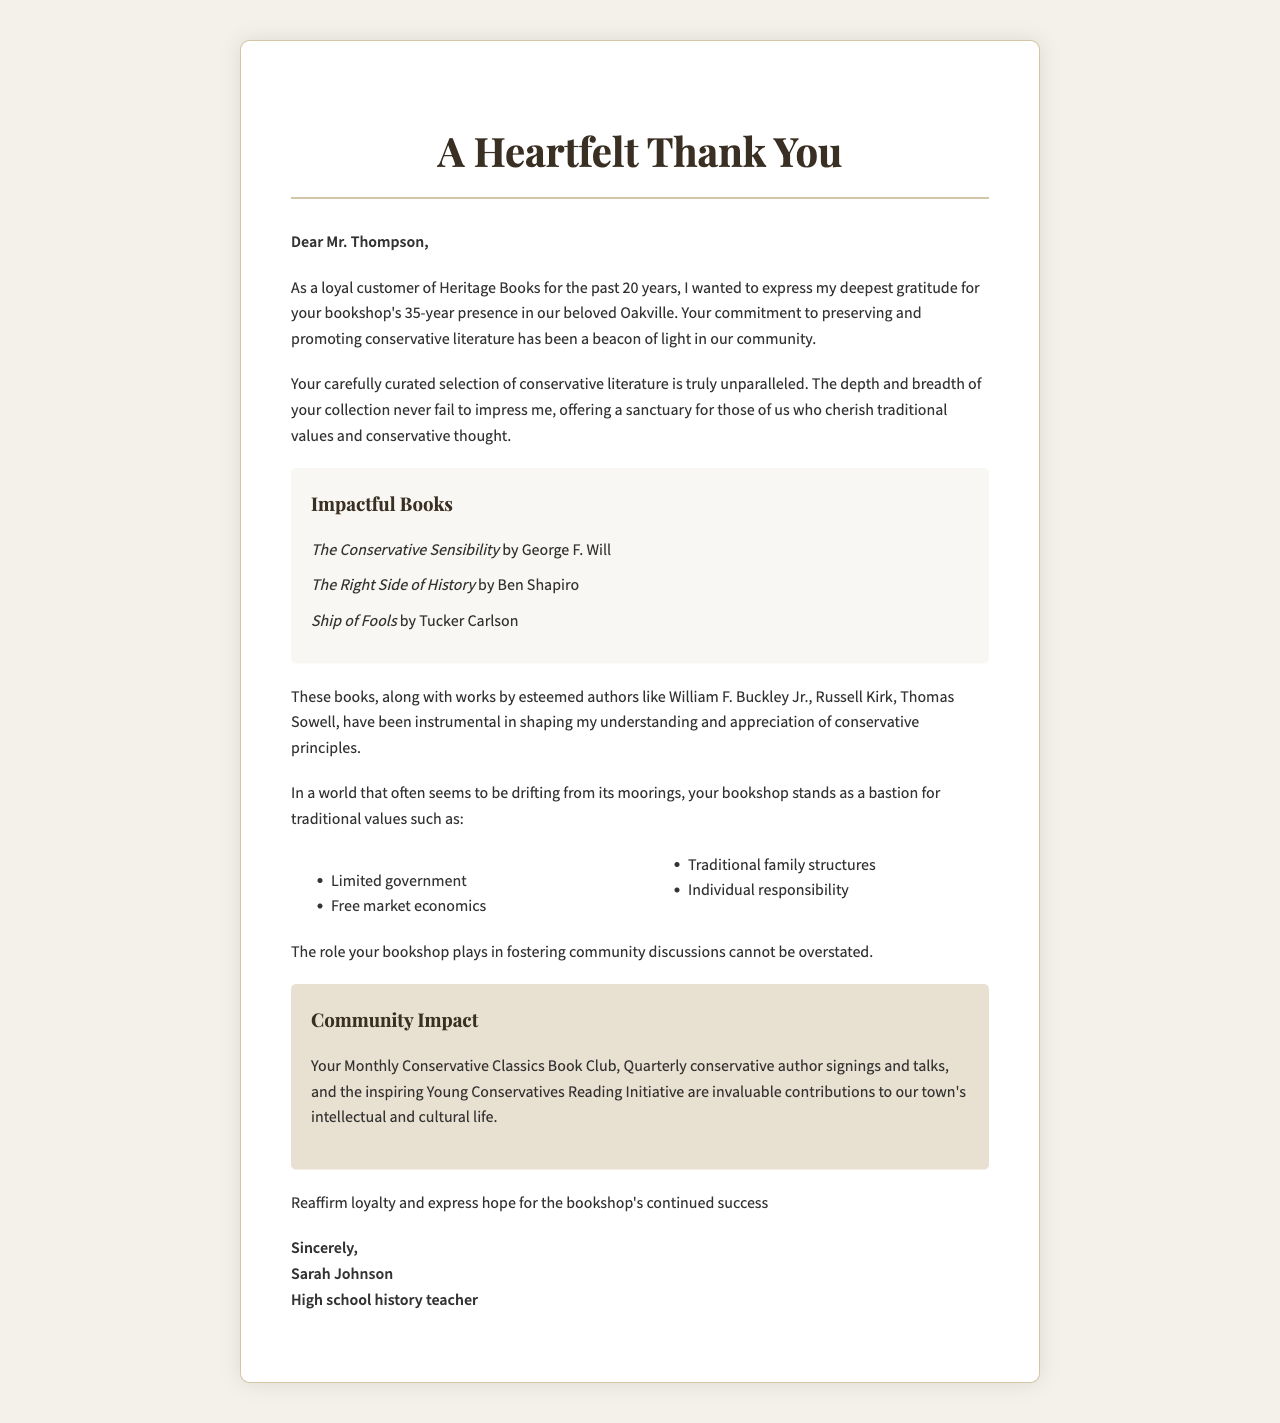What is the name of the bookshop? The bookshop is referred to as Heritage Books in the document.
Answer: Heritage Books How many years has the bookshop been in business? The document states that the bookshop has been operating for 35 years.
Answer: 35 Who wrote "The Conservative Sensibility"? The letter mentions George F. Will as the author of this book.
Answer: George F. Will What is the customer's occupation? The document describes the customer as a high school history teacher.
Answer: High school history teacher What community program is mentioned in the letter? The letter refers to the Young Conservatives Reading Initiative as a community program.
Answer: Young Conservatives Reading Initiative Which conservative value is listed as "Limited government"? This item is included in the list of traditional values emphasized in the letter.
Answer: Limited government What specific event does the bookshop hold quarterly? The document indicates that the bookshop hosts quarterly conservative author signings and talks.
Answer: Conservative author signings and talks What is the salutation used in the letter? The letter starts with "Dear Mr. Thompson," as the salutation.
Answer: Dear Mr. Thompson Who is the customer expressing gratitude to? The customer is expressing gratitude specifically to Mr. Thompson, the owner.
Answer: Mr. Thompson 